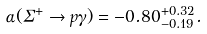Convert formula to latex. <formula><loc_0><loc_0><loc_500><loc_500>\alpha ( \Sigma ^ { + } \to p \gamma ) = - 0 . 8 0 ^ { + 0 . 3 2 } _ { - 0 . 1 9 } .</formula> 